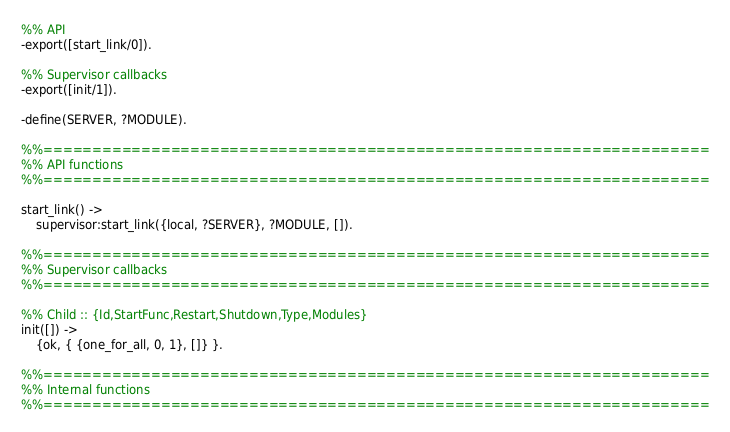<code> <loc_0><loc_0><loc_500><loc_500><_Erlang_>%% API
-export([start_link/0]).

%% Supervisor callbacks
-export([init/1]).

-define(SERVER, ?MODULE).

%%====================================================================
%% API functions
%%====================================================================

start_link() ->
    supervisor:start_link({local, ?SERVER}, ?MODULE, []).

%%====================================================================
%% Supervisor callbacks
%%====================================================================

%% Child :: {Id,StartFunc,Restart,Shutdown,Type,Modules}
init([]) ->
    {ok, { {one_for_all, 0, 1}, []} }.

%%====================================================================
%% Internal functions
%%====================================================================
</code> 